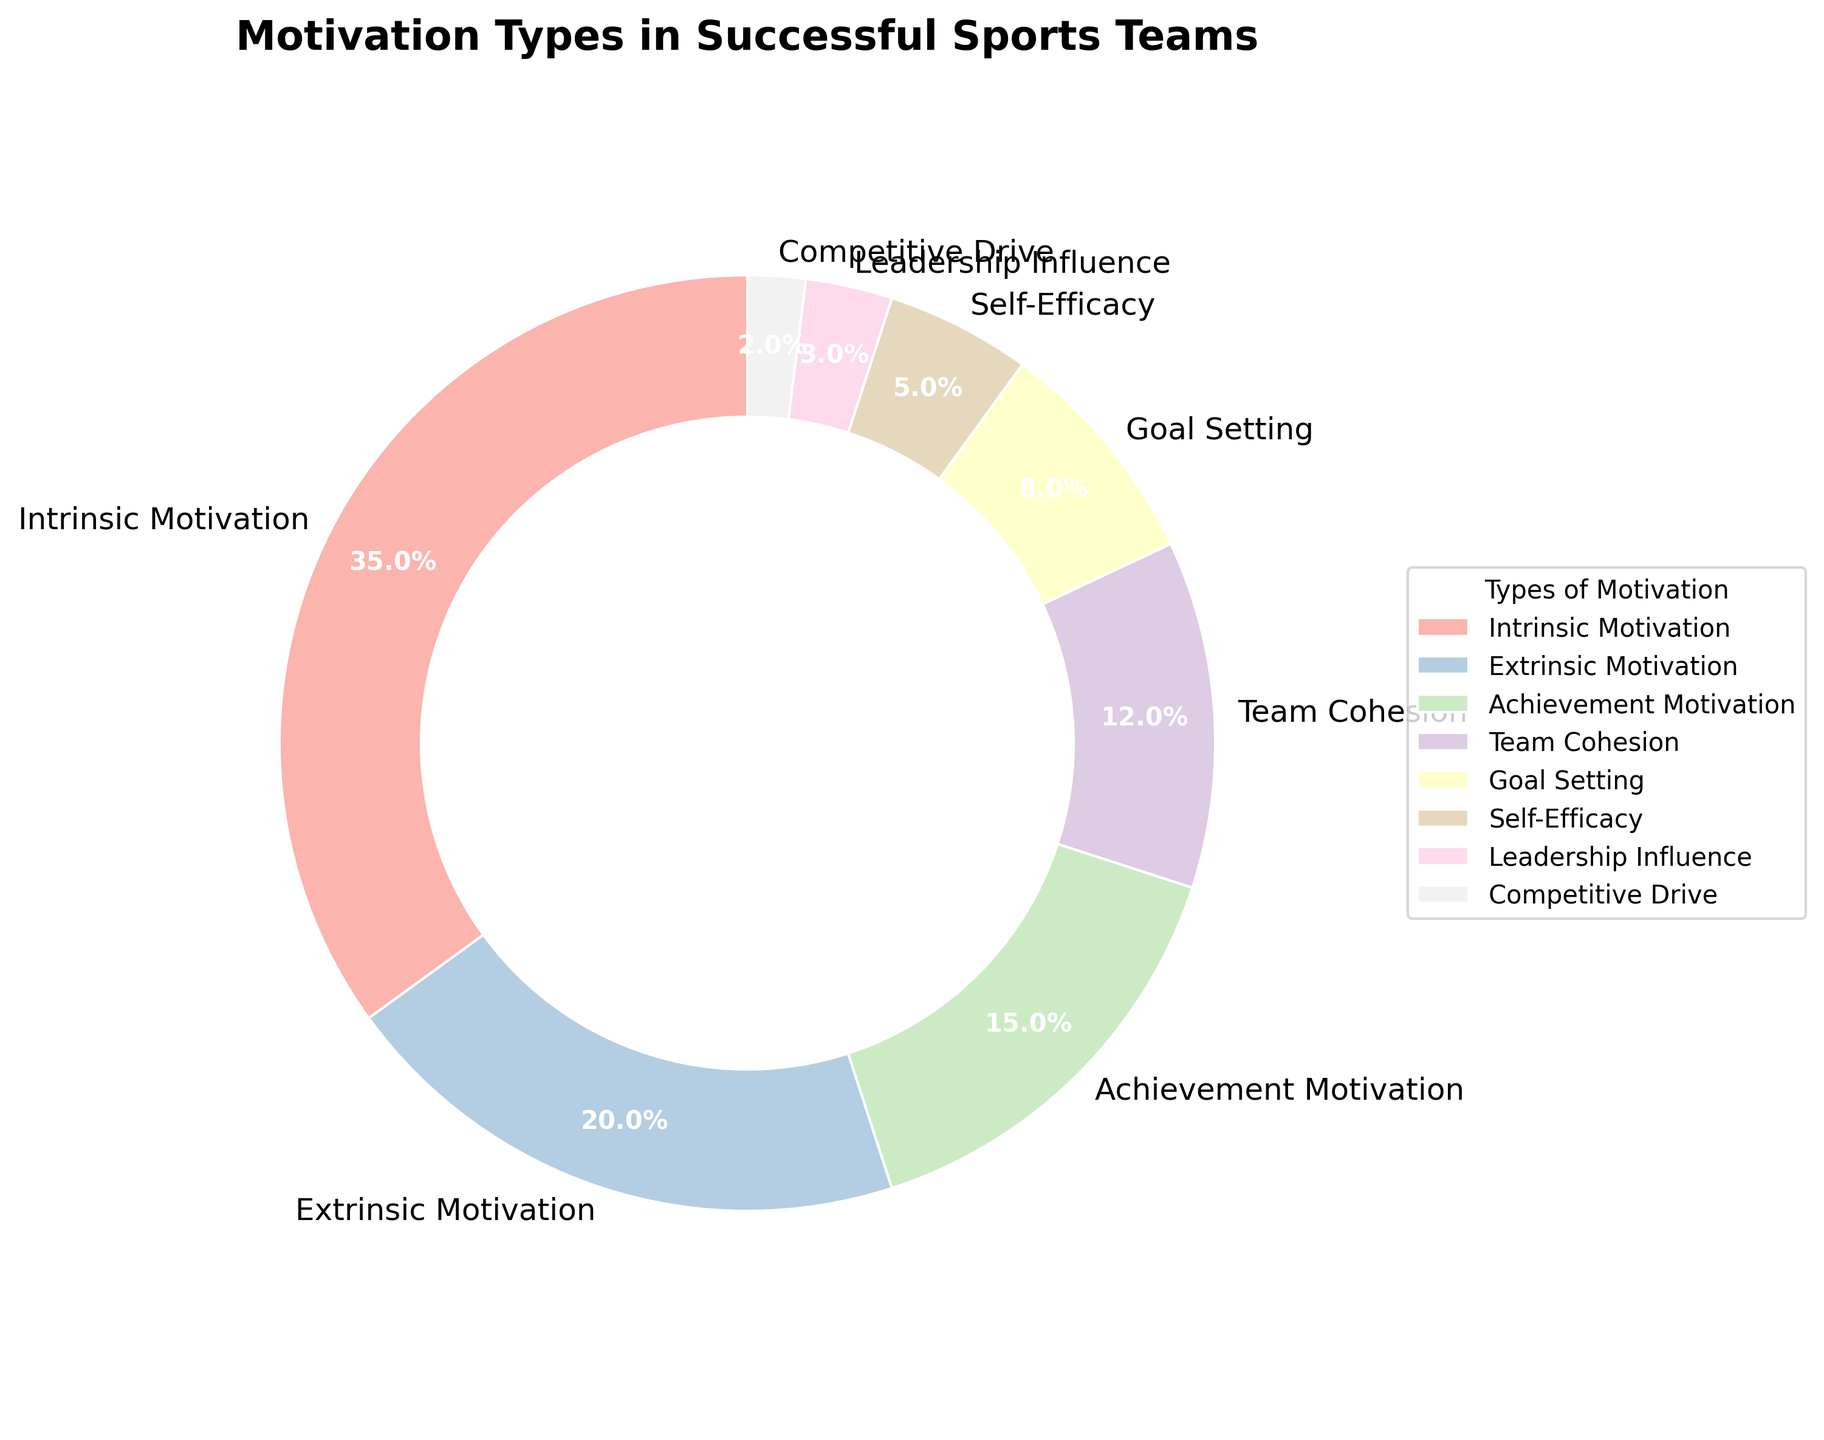What is the percentage of Intrinsic Motivation in successful sports teams? The figure shows a pie chart with percentages for different types of motivation. Intrinsic Motivation is labeled with 35%.
Answer: 35% What is the combined percentage of Extrinsic Motivation and Achievement Motivation? To find the combined percentage, add the percentages of Extrinsic Motivation (20%) and Achievement Motivation (15%). So, 20% + 15% = 35%.
Answer: 35% Which motivation type has the smallest percentage, and what is that percentage? By looking at the figure, Competitive Drive has the smallest percentage, which is labeled as 2%.
Answer: Competitive Drive, 2% How much larger, in percentage points, is Intrinsic Motivation compared to Team Cohesion? Subtract the percentage of Team Cohesion (12%) from Intrinsic Motivation (35%). So, 35% - 12% = 23%.
Answer: 23% What is the total percentage of motivation types related to individual factors (Intrinsic Motivation, Extrinsic Motivation, Achievement Motivation, and Self-Efficacy)? Sum the percentages of Intrinsic Motivation (35%), Extrinsic Motivation (20%), Achievement Motivation (15%), and Self-Efficacy (5%). So, 35% + 20% + 15% + 5% = 75%.
Answer: 75% Is the percentage of Goal Setting higher than that of Self-Efficacy? Compare the percentages for Goal Setting (8%) and Self-Efficacy (5%). Since 8% > 5%, Goal Setting is higher.
Answer: Yes What is the difference in percentage points between Leadership Influence and Competitive Drive? Subtract the percentage of Competitive Drive (2%) from Leadership Influence (3%). So, 3% - 2% = 1%.
Answer: 1% Which type of motivation represents over one-third of the total motivation types? One-third of 100% is approximately 33.33%. Intrinsic Motivation is the only motivation type over this threshold, with 35%.
Answer: Intrinsic Motivation Which color represents Goal Setting, and what percentage does it account for? The figure uses different colors for each section. Identify the color labeled as Goal Setting, which accounts for 8%.
Answer: Depends on the color, 8% How many motivation types have a percentage of at least 10%? By examining the figure, the motivation types with at least 10% are Intrinsic Motivation (35%), Extrinsic Motivation (20%), and Achievement Motivation (15%). That's 3 types.
Answer: 3 